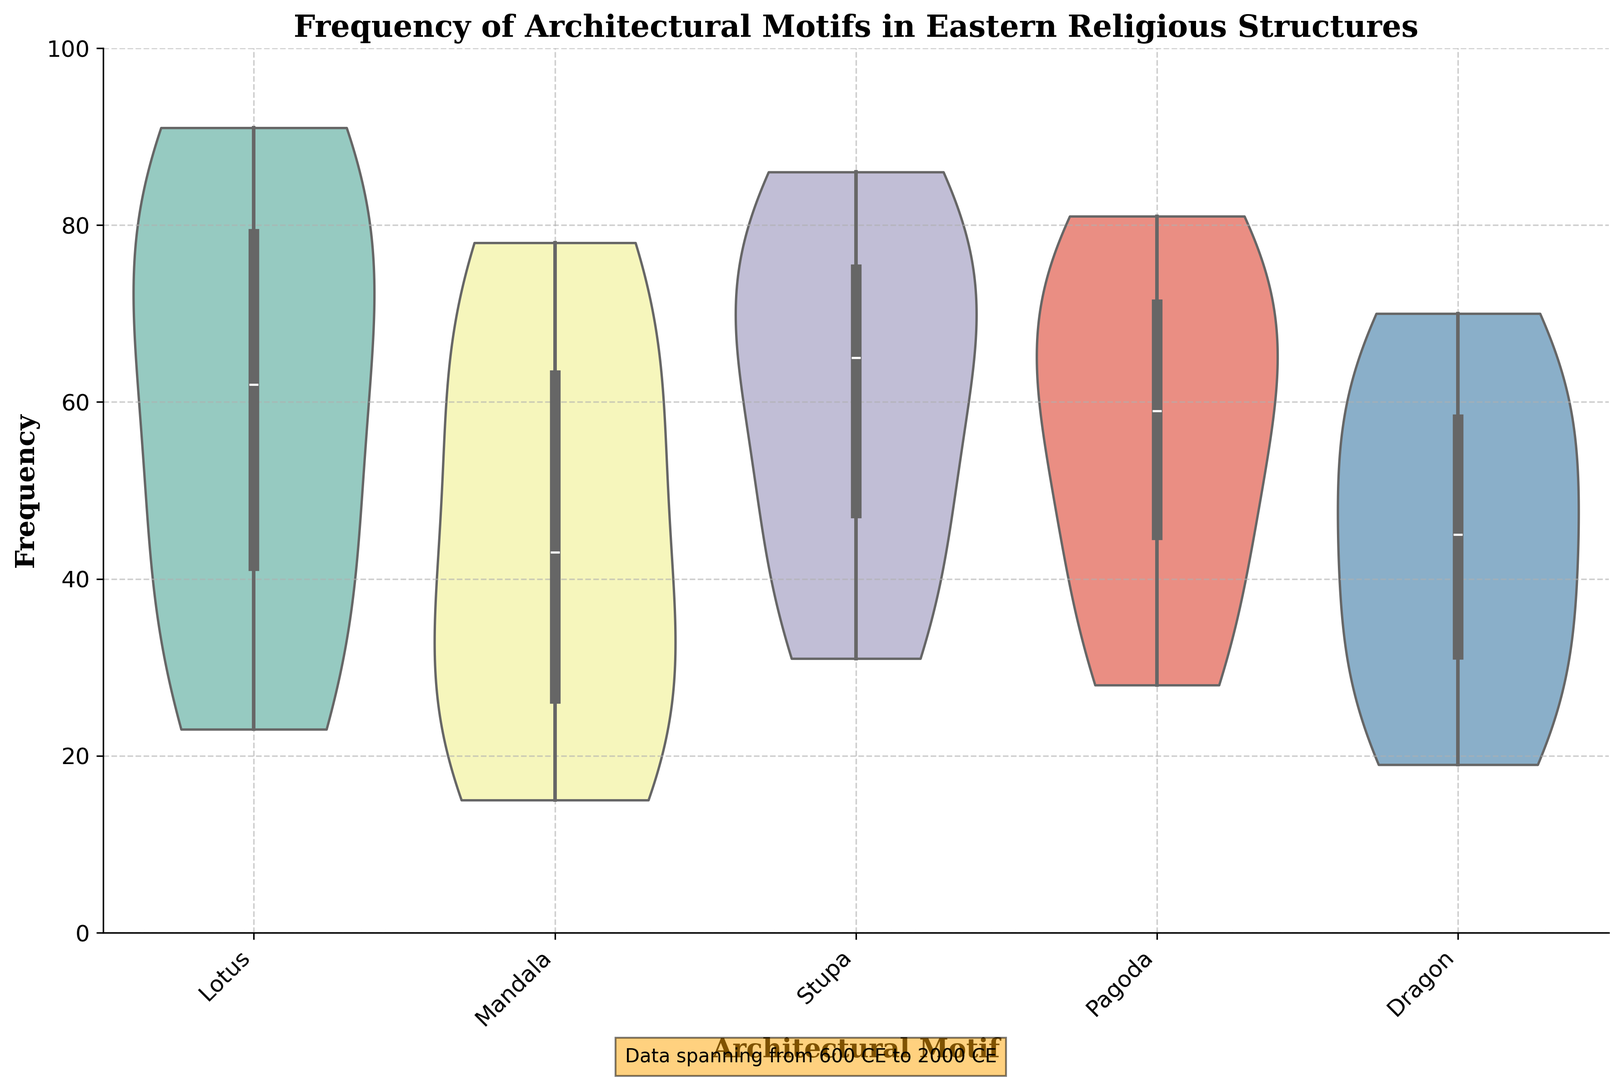What is the median frequency of the 'Stupa' motif? The median is the middle value: in the figure, 'Stupa' frequencies get spaced out over the periods. From 600-2000 CE, the median appears around the middle range of each violin, likely less than 75.
Answer: Just above 60 Which motif has the broadest range and how can you tell? The broadest range means the widest spread of frequencies in the figure. From visual inspection, the 'Stupa' motif appears to have the widest distribution range extending from the bottom to the top of the y-axis.
Answer: Stupa Are any motifs showing significant changes in distribution over time? By comparing the width and spread of each violin's distribution for different motifs, 'Lotus' and 'Pagoda' show notable changes; becoming broader and higher as you move from 600 CE to 2000 CE.
Answer: Lotus and Pagoda How does the frequency distribution of the 'Dragon' motif compare to the 'Lotus' motif? Comparing the violins for 'Dragon' and 'Lotus' shows that 'Lotus' has higher frequency peaks and broader distribution overall, indicating higher frequency and variation through the periods.
Answer: Dragon has a lower and narrower distribution compared to Lotus What is the difference in maximum frequencies between 'Mandala' and 'Pagoda' motifs in more recent periods? Inspecting the figure reveals that in the 1800-2000 CE period, the maximum frequencies for 'Mandala' and 'Pagoda' appear to differ significantly; with 'Pagoda' having a slightly higher frequency. The difference can be observed in the highest values of their violins.
Answer: Around 3-9 Which motif shows a consistent increase in frequency over the centuries? By observing the general trend lines formed within the violins, 'Lotus' shows a clear and consistent increase in frequency from 600 to 2000 CE, reflected in the heightening and broadening of the violins through the periods.
Answer: Lotus How do the frequency distributions for 'Pagoda' motif look from 1200 to 1600 CE? Focusing on 'Pagoda' from 1200-1600 CE shows a visible upward trend with relatively wider and slightly more spread-out distributions, indicating increased frequency and variability in these centuries.
Answer: Increasing frequency, wider distribution Which two motifs have the closest median frequencies in the 1600-1800 CE period? By measuring the midpoints (medians) in the 1600-1800 CE period for all motifs, 'Lotus' and 'Mandala' show closest median frequencies based on their violin shapes and placements within the y-axis.
Answer: Lotus and Mandala 